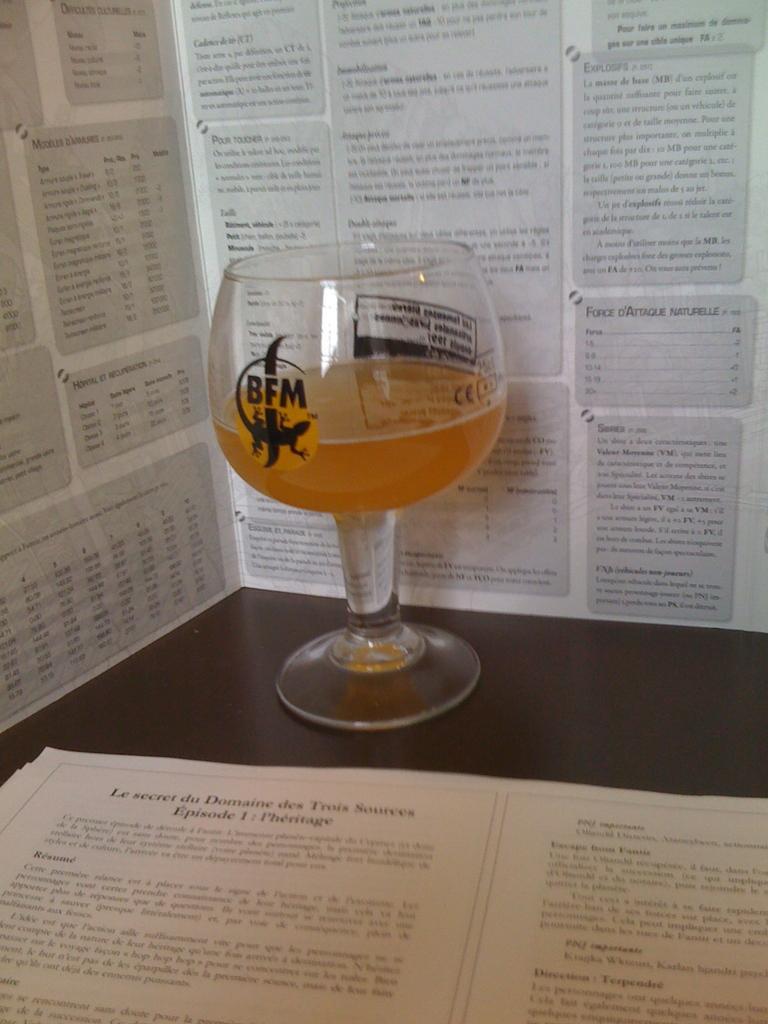How would you summarize this image in a sentence or two? In this image there is a glass with the drink in it. At the bottom there is a paper on which there is some script. In the background there is a wall on which there are articles. 